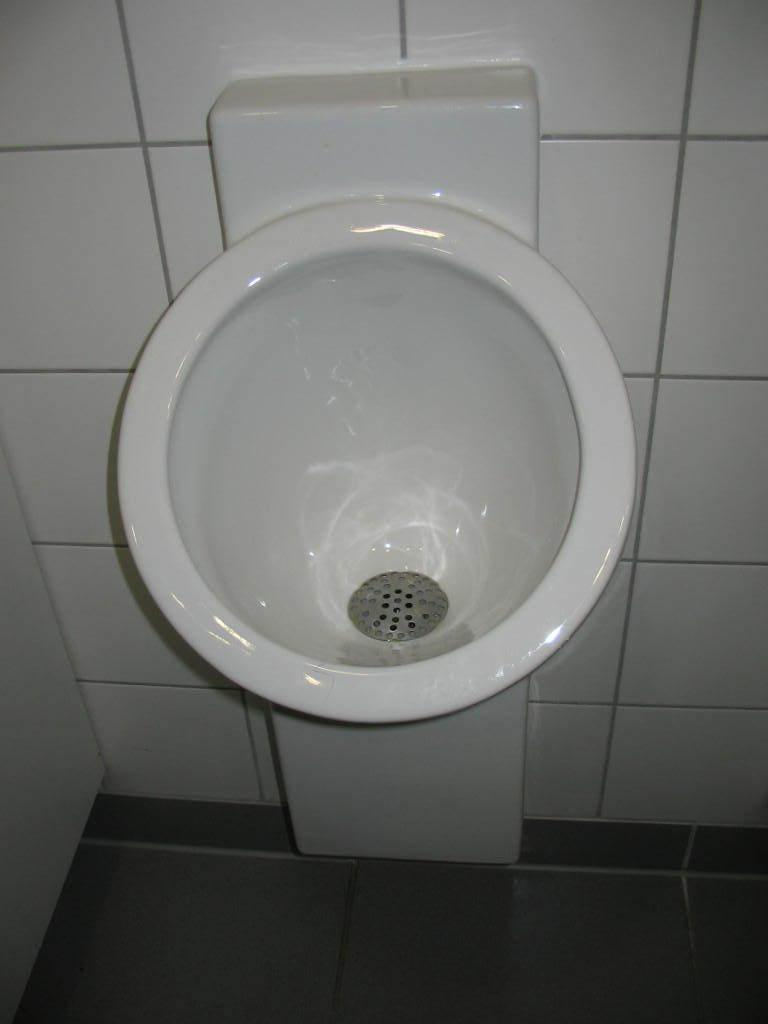What is the main object in the image? There is a washbasin in the image. What can be seen in the background of the image? There are tiles visible in the background of the image. What type of pets are sitting on the edge of the washbasin in the image? There are no pets present in the image; it only features a washbasin and tiles in the background. 